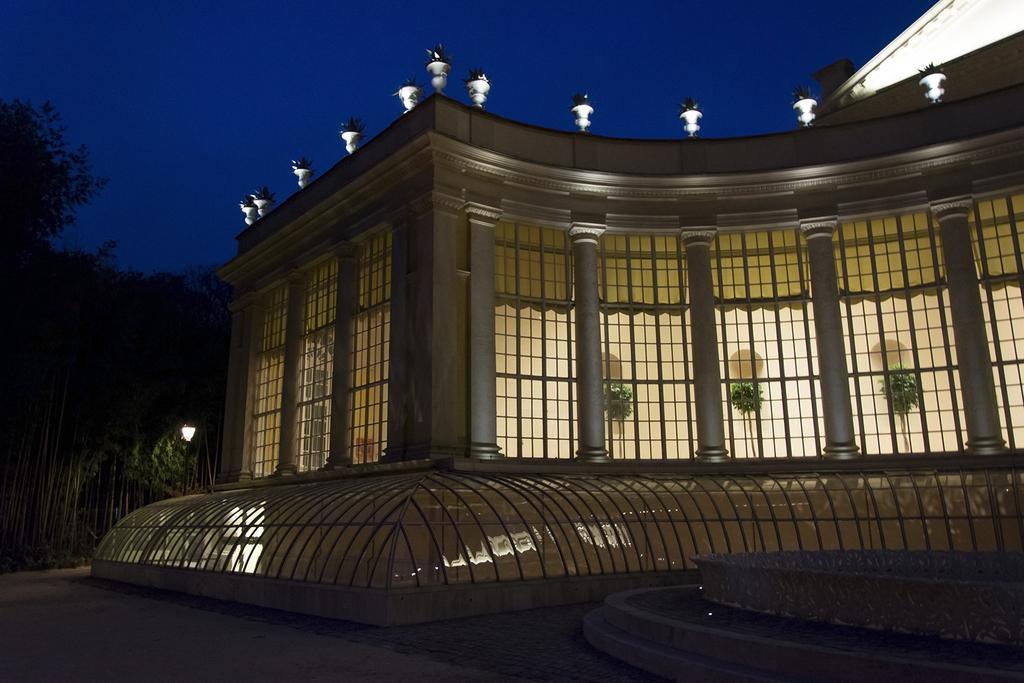Please provide a concise description of this image. This image is taken during the night time. In this image we can see the building with the windows, plants, flower pots. We can also see the light pole, trees and also the path. At the top we can see the sky. 